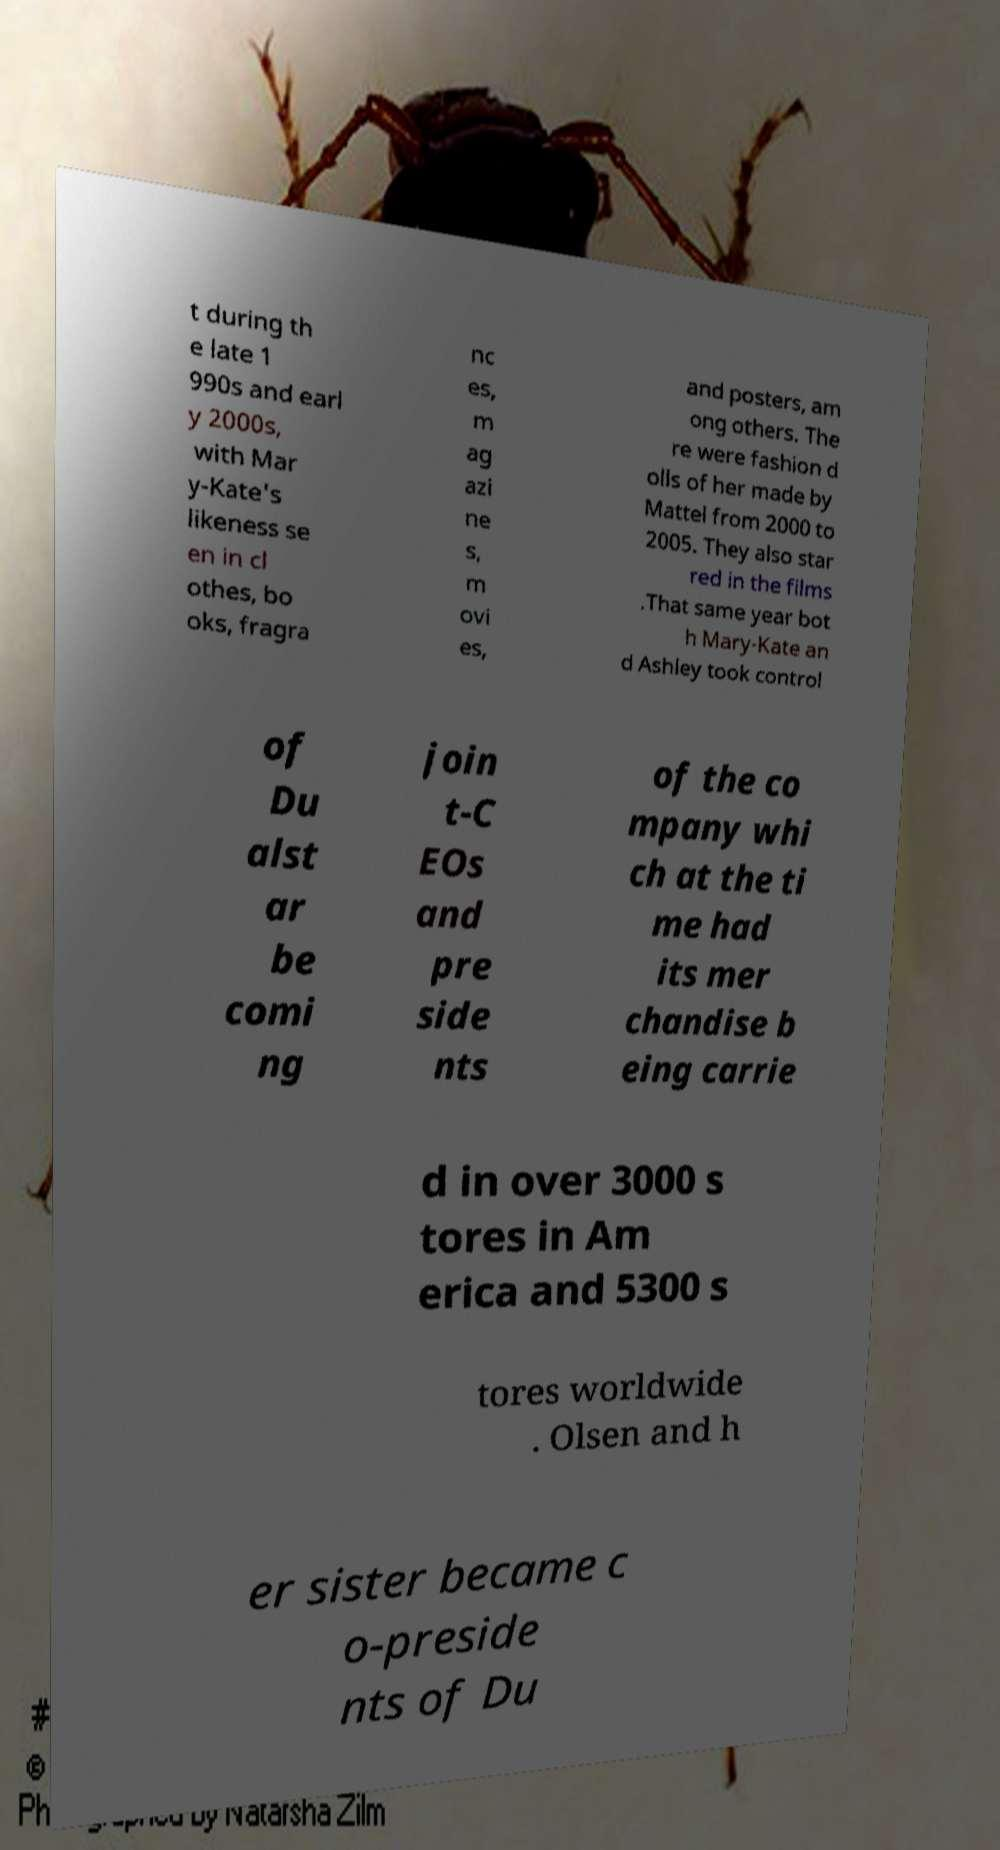For documentation purposes, I need the text within this image transcribed. Could you provide that? t during th e late 1 990s and earl y 2000s, with Mar y-Kate's likeness se en in cl othes, bo oks, fragra nc es, m ag azi ne s, m ovi es, and posters, am ong others. The re were fashion d olls of her made by Mattel from 2000 to 2005. They also star red in the films .That same year bot h Mary-Kate an d Ashley took control of Du alst ar be comi ng join t-C EOs and pre side nts of the co mpany whi ch at the ti me had its mer chandise b eing carrie d in over 3000 s tores in Am erica and 5300 s tores worldwide . Olsen and h er sister became c o-preside nts of Du 